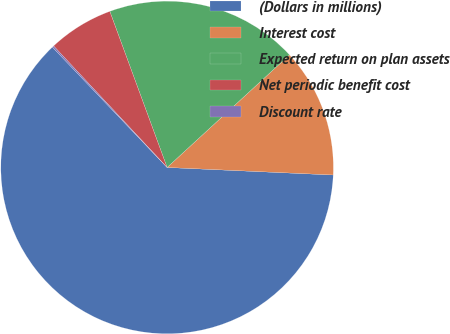Convert chart to OTSL. <chart><loc_0><loc_0><loc_500><loc_500><pie_chart><fcel>(Dollars in millions)<fcel>Interest cost<fcel>Expected return on plan assets<fcel>Net periodic benefit cost<fcel>Discount rate<nl><fcel>62.15%<fcel>12.56%<fcel>18.76%<fcel>6.36%<fcel>0.16%<nl></chart> 